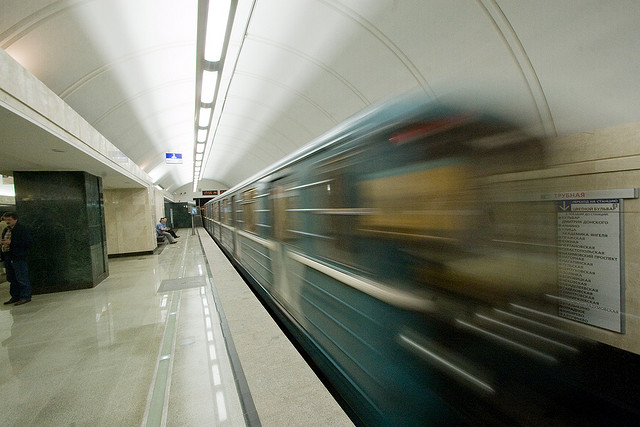Is the overall lighting in the image sufficient?
 Yes 